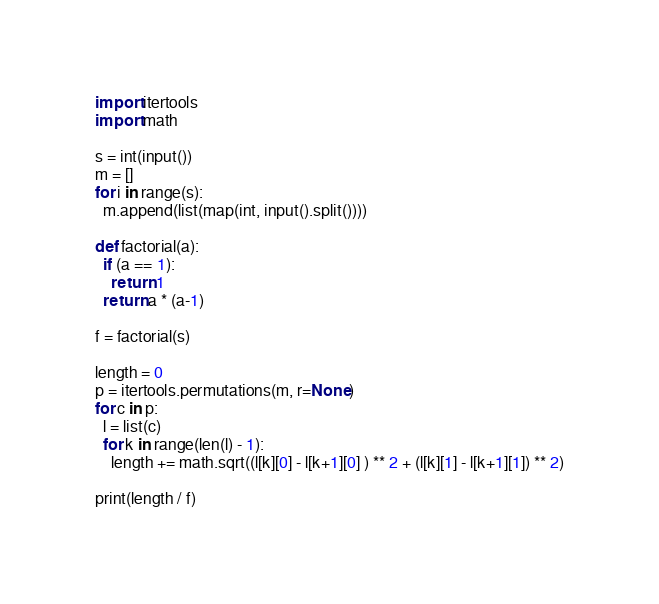Convert code to text. <code><loc_0><loc_0><loc_500><loc_500><_Python_>import itertools
import math

s = int(input())
m = []
for i in range(s):
  m.append(list(map(int, input().split())))

def factorial(a):
  if (a == 1):
    return 1
  return a * (a-1)

f = factorial(s)

length = 0
p = itertools.permutations(m, r=None)
for c in p:
  l = list(c)
  for k in range(len(l) - 1):
    length += math.sqrt((l[k][0] - l[k+1][0] ) ** 2 + (l[k][1] - l[k+1][1]) ** 2)

print(length / f)
</code> 